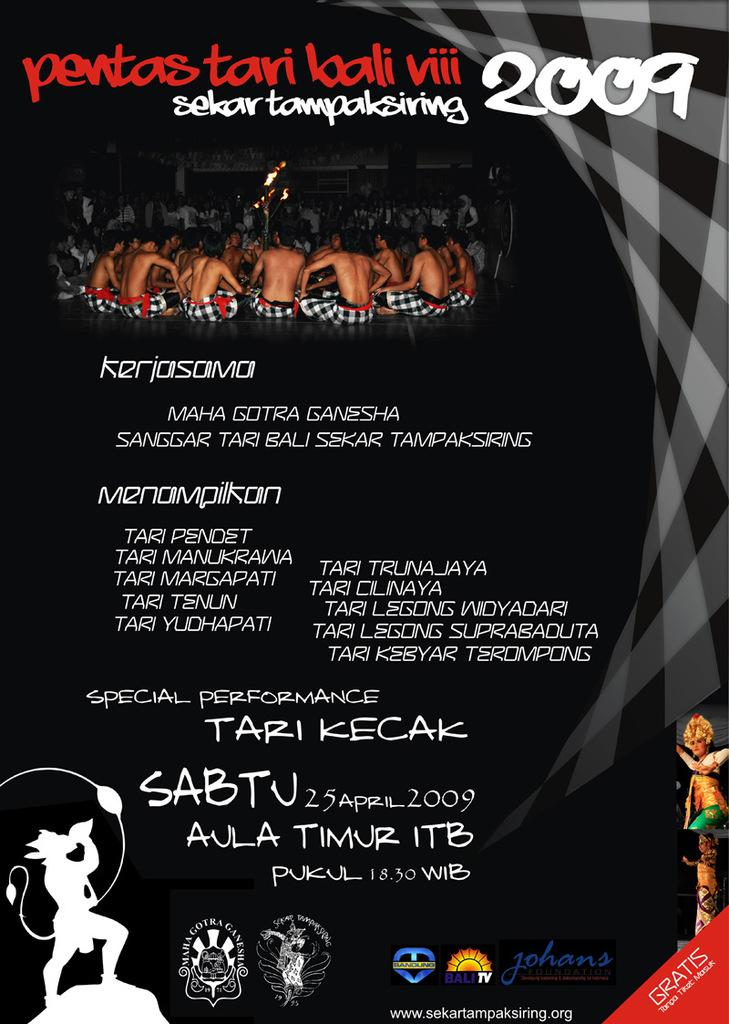Provide a one-sentence caption for the provided image. A poster for an event with a date of 25 April 2009. 